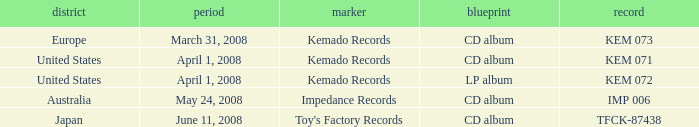Which Region has a Catalog of kem 072? United States. 